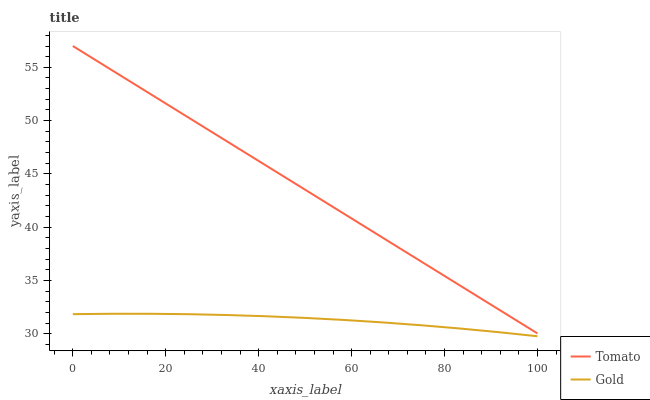Does Gold have the minimum area under the curve?
Answer yes or no. Yes. Does Tomato have the maximum area under the curve?
Answer yes or no. Yes. Does Gold have the maximum area under the curve?
Answer yes or no. No. Is Tomato the smoothest?
Answer yes or no. Yes. Is Gold the roughest?
Answer yes or no. Yes. Is Gold the smoothest?
Answer yes or no. No. Does Gold have the lowest value?
Answer yes or no. Yes. Does Tomato have the highest value?
Answer yes or no. Yes. Does Gold have the highest value?
Answer yes or no. No. Is Gold less than Tomato?
Answer yes or no. Yes. Is Tomato greater than Gold?
Answer yes or no. Yes. Does Gold intersect Tomato?
Answer yes or no. No. 